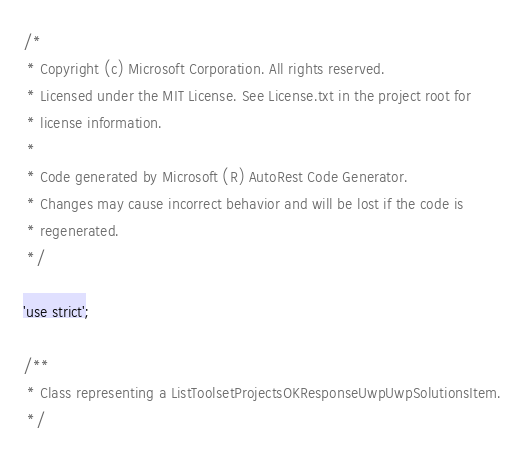Convert code to text. <code><loc_0><loc_0><loc_500><loc_500><_JavaScript_>/*
 * Copyright (c) Microsoft Corporation. All rights reserved.
 * Licensed under the MIT License. See License.txt in the project root for
 * license information.
 *
 * Code generated by Microsoft (R) AutoRest Code Generator.
 * Changes may cause incorrect behavior and will be lost if the code is
 * regenerated.
 */

'use strict';

/**
 * Class representing a ListToolsetProjectsOKResponseUwpUwpSolutionsItem.
 */</code> 